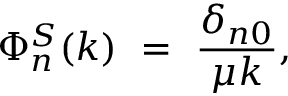<formula> <loc_0><loc_0><loc_500><loc_500>\Phi _ { n } ^ { S } ( k ) = \frac { \delta _ { n 0 } } { \mu k } ,</formula> 